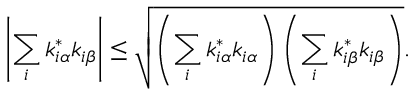<formula> <loc_0><loc_0><loc_500><loc_500>\left | \sum _ { i } k _ { i \alpha } ^ { * } k _ { i \beta } \right | \leq \sqrt { \left ( \sum _ { i } k _ { i \alpha } ^ { * } k _ { i \alpha } \right ) \left ( \sum _ { i } k _ { i \beta } ^ { * } k _ { i \beta } \right ) } .</formula> 